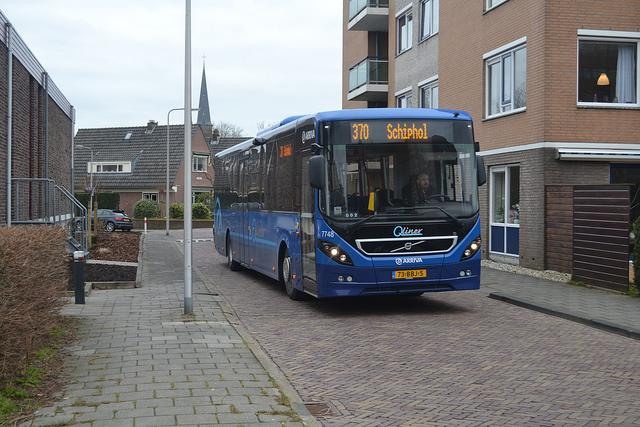What do people do inside the building with the spire on it?

Choices:
A) play chess
B) worship
C) party
D) eat out worship 